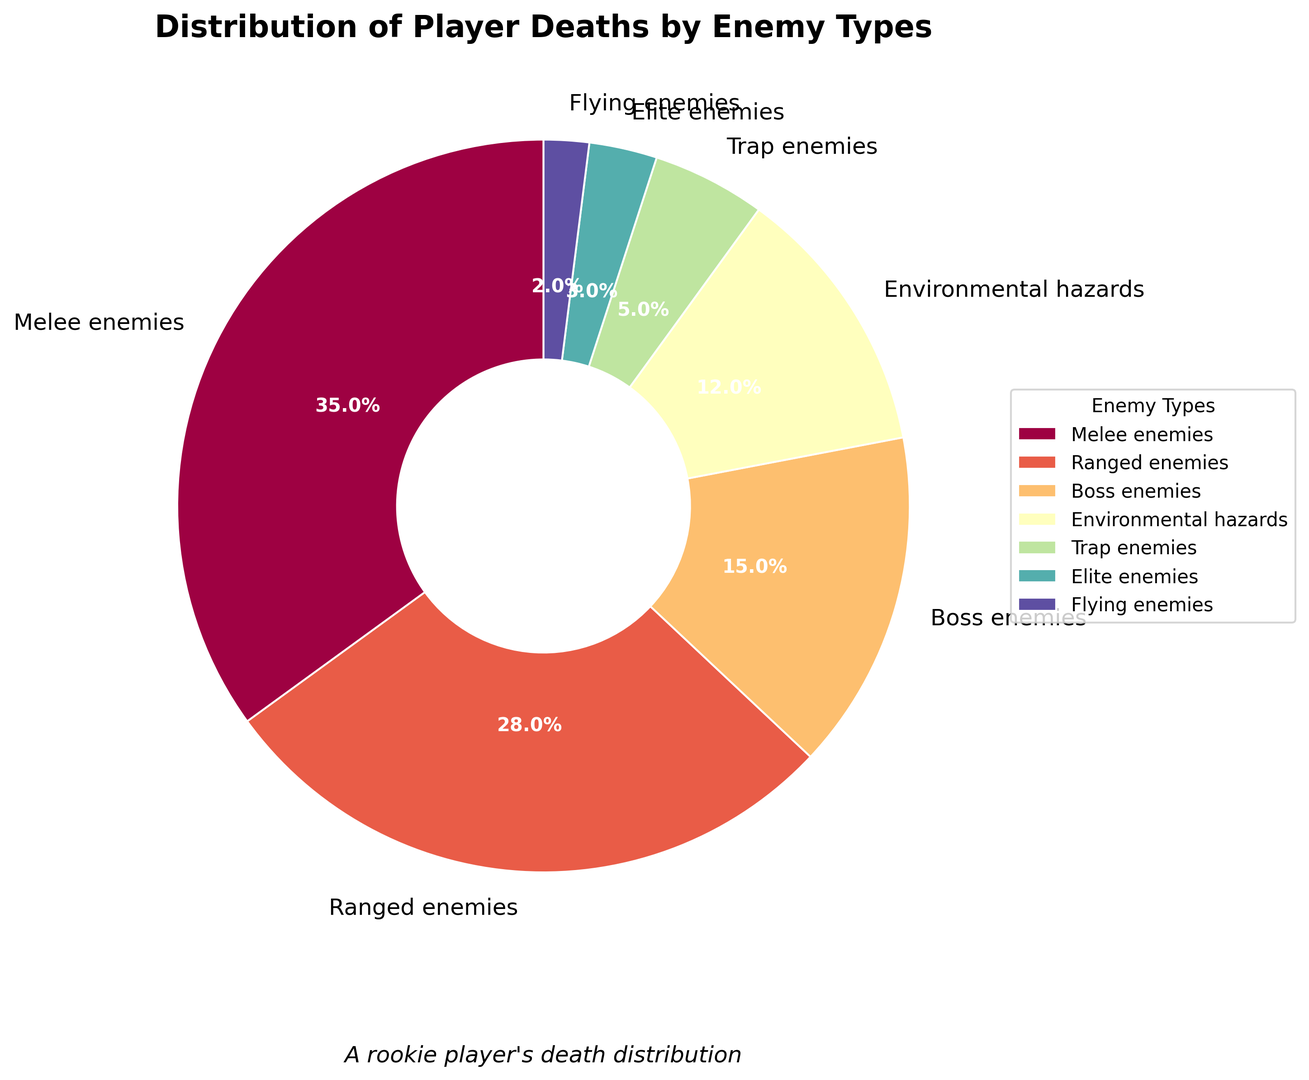Which enemy type causes the most player deaths? The pie chart shows the percentages of player deaths by different enemy types. The largest slice corresponds to "Melee enemies" with 35%.
Answer: Melee enemies What percentage of player deaths are caused by Ranged enemies compared to Boss enemies? The pie chart indicates that Ranged enemies account for 28% of player deaths, while Boss enemies account for 15%. To compare, we divide 28 by 15, resulting in approximately 1.87 times more deaths caused by Ranged enemies.
Answer: 1.87 times more What is the combined percentage of player deaths caused by Environmental hazards and Trap enemies? From the pie chart, Environmental hazards cause 12% of player deaths, and Trap enemies cause 5%. Adding these percentages together gives 12% + 5% = 17%.
Answer: 17% Which enemy type is responsible for the second lowest percentage of player deaths? Looking at the pie chart, the second smallest slice corresponds to "Flying enemies" which account for 2% of player deaths.
Answer: Flying enemies Are more player deaths caused by Ranged enemies or by both Trap and Elite enemies combined? The pie chart indicates that Ranged enemies account for 28% of player deaths. The combined percentage for Trap enemies (5%) and Elite enemies (3%) is 5% + 3% = 8%. Since 28% is greater than 8%, Ranged enemies cause more deaths.
Answer: Ranged enemies What is the difference in player death percentages between Melee enemies and Environmental hazards? From the pie chart, Melee enemies cause 35% of player deaths, and Environmental hazards cause 12%. The difference is 35% - 12% = 23%.
Answer: 23% What percentage of player deaths are due to enemies listed in the chart excluding Boss enemies? The percentages for enemy types other than Boss enemies (15%) can be added: 35% (Melee) + 28% (Ranged) + 12% (Environmental hazards) + 5% (Trap) + 3% (Elite) + 2% (Flying) = 85%.
Answer: 85% What color represents the enemy type responsible for the least player deaths, and what percentage does it account for? Based on the visual attributes of the pie chart, the smallest slice representing "Flying enemies" (2%) is light-colored. Specifically identifying the color is based on the figure but assume it is a light shade in the scheme used.
Answer: Light shade, 2% Which two enemy types together account for more player deaths, Ranged and Elite enemies or Environmental hazards and Trap enemies? From the pie chart, Ranged enemies account for 28% and Elite enemies for 3%, summing to 28% + 3% = 31%. Environmental hazards account for 12% and Trap enemies for 5%, summing to 12% + 5% = 17%. Therefore, Ranged and Elite enemies together account for more deaths.
Answer: Ranged and Elite enemies If you combine the percentages of player deaths caused by Melee, Ranged, and Boss enemies, what proportion of the total does this account for? Adding the percentages from the pie chart: Melee (35%), Ranged (28%), and Boss (15%) gives 35% + 28% + 15% = 78%. Hence, 78% of player deaths are due to these three enemy types.
Answer: 78% 